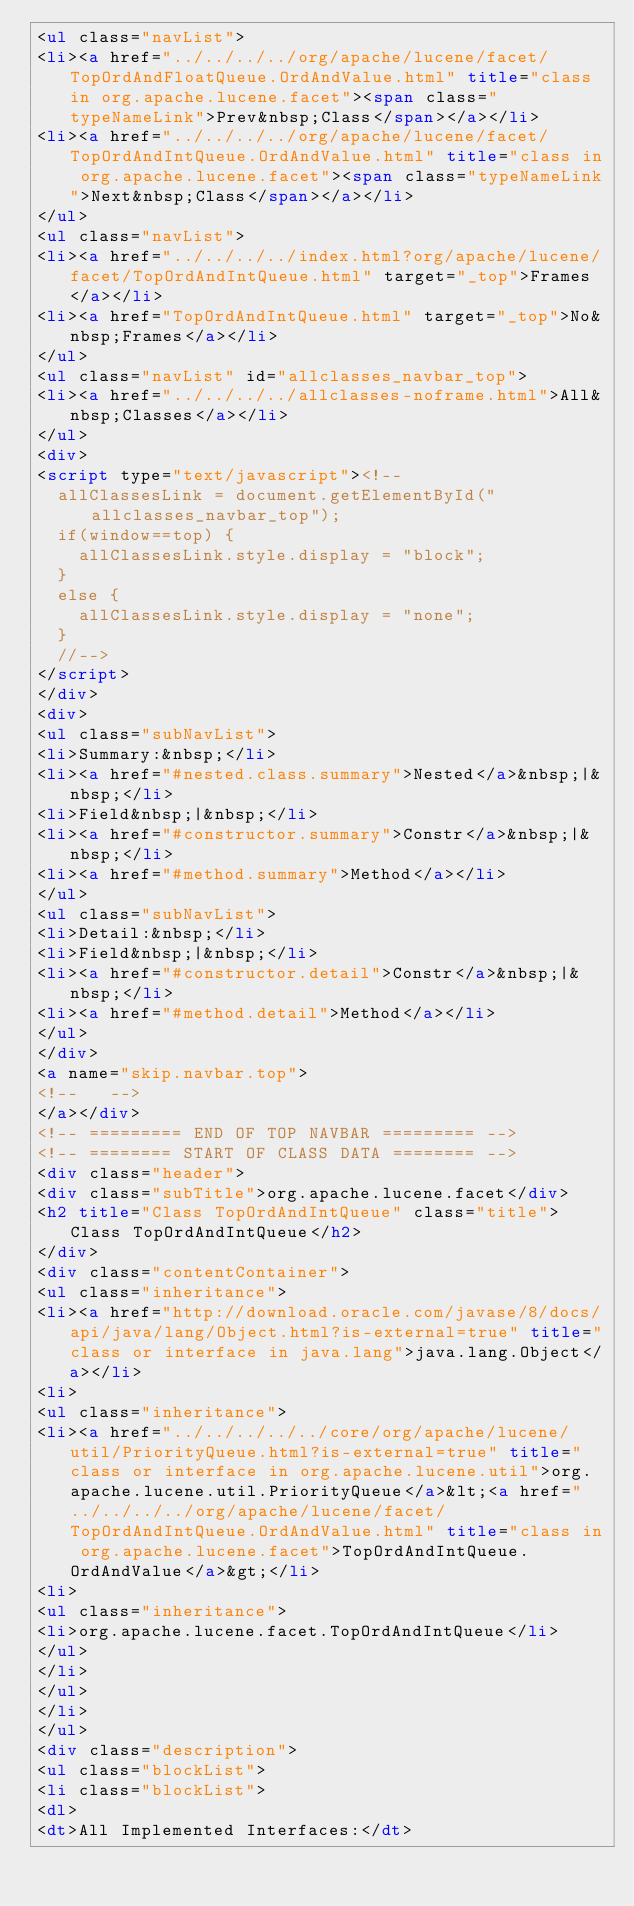<code> <loc_0><loc_0><loc_500><loc_500><_HTML_><ul class="navList">
<li><a href="../../../../org/apache/lucene/facet/TopOrdAndFloatQueue.OrdAndValue.html" title="class in org.apache.lucene.facet"><span class="typeNameLink">Prev&nbsp;Class</span></a></li>
<li><a href="../../../../org/apache/lucene/facet/TopOrdAndIntQueue.OrdAndValue.html" title="class in org.apache.lucene.facet"><span class="typeNameLink">Next&nbsp;Class</span></a></li>
</ul>
<ul class="navList">
<li><a href="../../../../index.html?org/apache/lucene/facet/TopOrdAndIntQueue.html" target="_top">Frames</a></li>
<li><a href="TopOrdAndIntQueue.html" target="_top">No&nbsp;Frames</a></li>
</ul>
<ul class="navList" id="allclasses_navbar_top">
<li><a href="../../../../allclasses-noframe.html">All&nbsp;Classes</a></li>
</ul>
<div>
<script type="text/javascript"><!--
  allClassesLink = document.getElementById("allclasses_navbar_top");
  if(window==top) {
    allClassesLink.style.display = "block";
  }
  else {
    allClassesLink.style.display = "none";
  }
  //-->
</script>
</div>
<div>
<ul class="subNavList">
<li>Summary:&nbsp;</li>
<li><a href="#nested.class.summary">Nested</a>&nbsp;|&nbsp;</li>
<li>Field&nbsp;|&nbsp;</li>
<li><a href="#constructor.summary">Constr</a>&nbsp;|&nbsp;</li>
<li><a href="#method.summary">Method</a></li>
</ul>
<ul class="subNavList">
<li>Detail:&nbsp;</li>
<li>Field&nbsp;|&nbsp;</li>
<li><a href="#constructor.detail">Constr</a>&nbsp;|&nbsp;</li>
<li><a href="#method.detail">Method</a></li>
</ul>
</div>
<a name="skip.navbar.top">
<!--   -->
</a></div>
<!-- ========= END OF TOP NAVBAR ========= -->
<!-- ======== START OF CLASS DATA ======== -->
<div class="header">
<div class="subTitle">org.apache.lucene.facet</div>
<h2 title="Class TopOrdAndIntQueue" class="title">Class TopOrdAndIntQueue</h2>
</div>
<div class="contentContainer">
<ul class="inheritance">
<li><a href="http://download.oracle.com/javase/8/docs/api/java/lang/Object.html?is-external=true" title="class or interface in java.lang">java.lang.Object</a></li>
<li>
<ul class="inheritance">
<li><a href="../../../../../core/org/apache/lucene/util/PriorityQueue.html?is-external=true" title="class or interface in org.apache.lucene.util">org.apache.lucene.util.PriorityQueue</a>&lt;<a href="../../../../org/apache/lucene/facet/TopOrdAndIntQueue.OrdAndValue.html" title="class in org.apache.lucene.facet">TopOrdAndIntQueue.OrdAndValue</a>&gt;</li>
<li>
<ul class="inheritance">
<li>org.apache.lucene.facet.TopOrdAndIntQueue</li>
</ul>
</li>
</ul>
</li>
</ul>
<div class="description">
<ul class="blockList">
<li class="blockList">
<dl>
<dt>All Implemented Interfaces:</dt></code> 